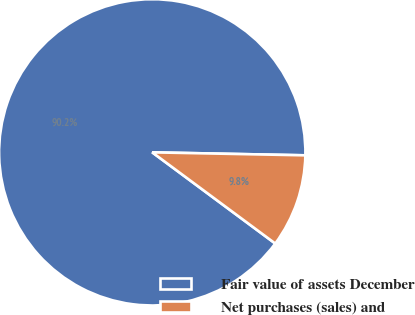Convert chart to OTSL. <chart><loc_0><loc_0><loc_500><loc_500><pie_chart><fcel>Fair value of assets December<fcel>Net purchases (sales) and<nl><fcel>90.16%<fcel>9.84%<nl></chart> 